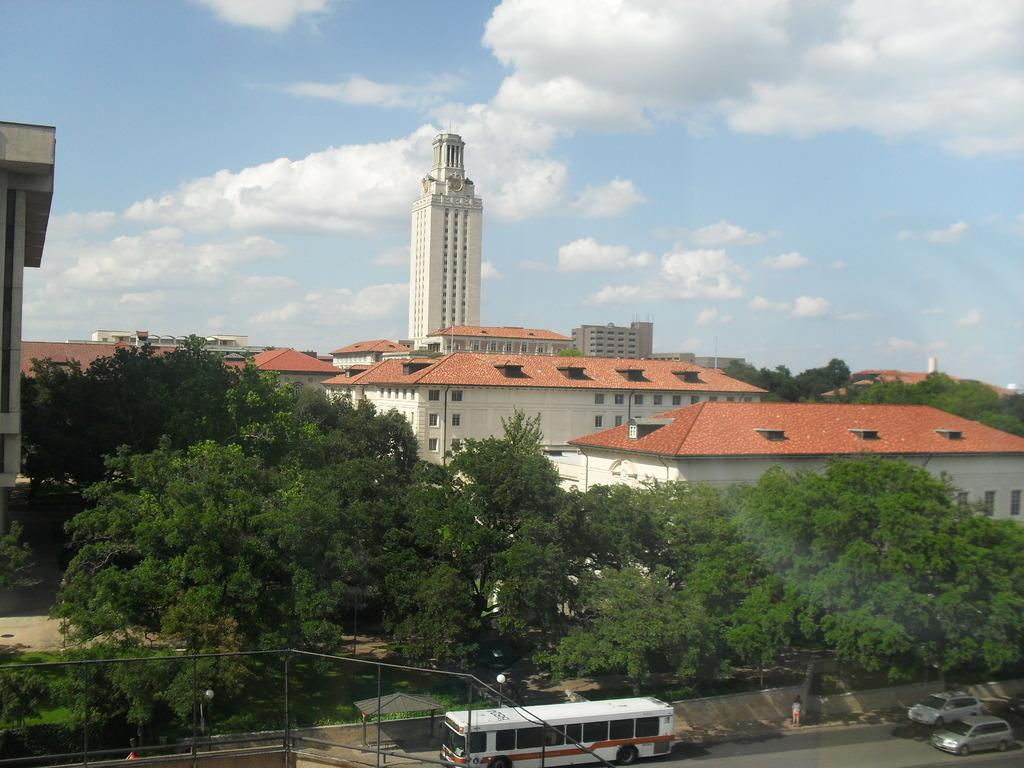What type of structures can be seen in the image? There are buildings in the image. What other natural elements are present in the image? There are trees in the image. What mode of transportation can be seen on the road in the image? There are vehicles on the road in the image. What type of barrier is present in the image? There is a fence in the image. What can be seen in the background of the image? The sky is visible in the background of the image. What type of mask is being worn by the trees in the image? There are no masks present in the image, as the trees are not wearing any. What is the smell of the buildings in the image? The image does not provide any information about the smell of the buildings, as it is a visual medium. 